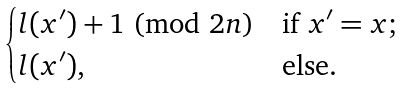Convert formula to latex. <formula><loc_0><loc_0><loc_500><loc_500>\begin{cases} l ( x ^ { \prime } ) + 1 \text { (mod $2n$)} & \text {if } x ^ { \prime } = x ; \\ l ( x ^ { \prime } ) , & \text {else.} \end{cases}</formula> 